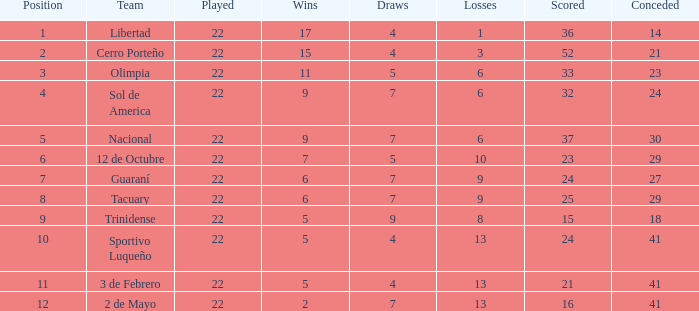Parse the full table. {'header': ['Position', 'Team', 'Played', 'Wins', 'Draws', 'Losses', 'Scored', 'Conceded'], 'rows': [['1', 'Libertad', '22', '17', '4', '1', '36', '14'], ['2', 'Cerro Porteño', '22', '15', '4', '3', '52', '21'], ['3', 'Olimpia', '22', '11', '5', '6', '33', '23'], ['4', 'Sol de America', '22', '9', '7', '6', '32', '24'], ['5', 'Nacional', '22', '9', '7', '6', '37', '30'], ['6', '12 de Octubre', '22', '7', '5', '10', '23', '29'], ['7', 'Guaraní', '22', '6', '7', '9', '24', '27'], ['8', 'Tacuary', '22', '6', '7', '9', '25', '29'], ['9', 'Trinidense', '22', '5', '9', '8', '15', '18'], ['10', 'Sportivo Luqueño', '22', '5', '4', '13', '24', '41'], ['11', '3 de Febrero', '22', '5', '4', '13', '21', '41'], ['12', '2 de Mayo', '22', '2', '7', '13', '16', '41']]} What is the total of draws for the side with more than 8 setbacks and 13 points? 7.0. 